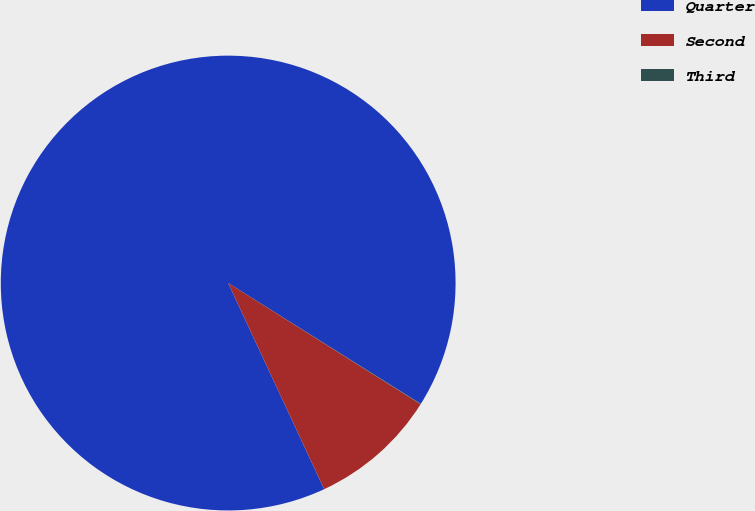Convert chart. <chart><loc_0><loc_0><loc_500><loc_500><pie_chart><fcel>Quarter<fcel>Second<fcel>Third<nl><fcel>90.85%<fcel>9.12%<fcel>0.03%<nl></chart> 